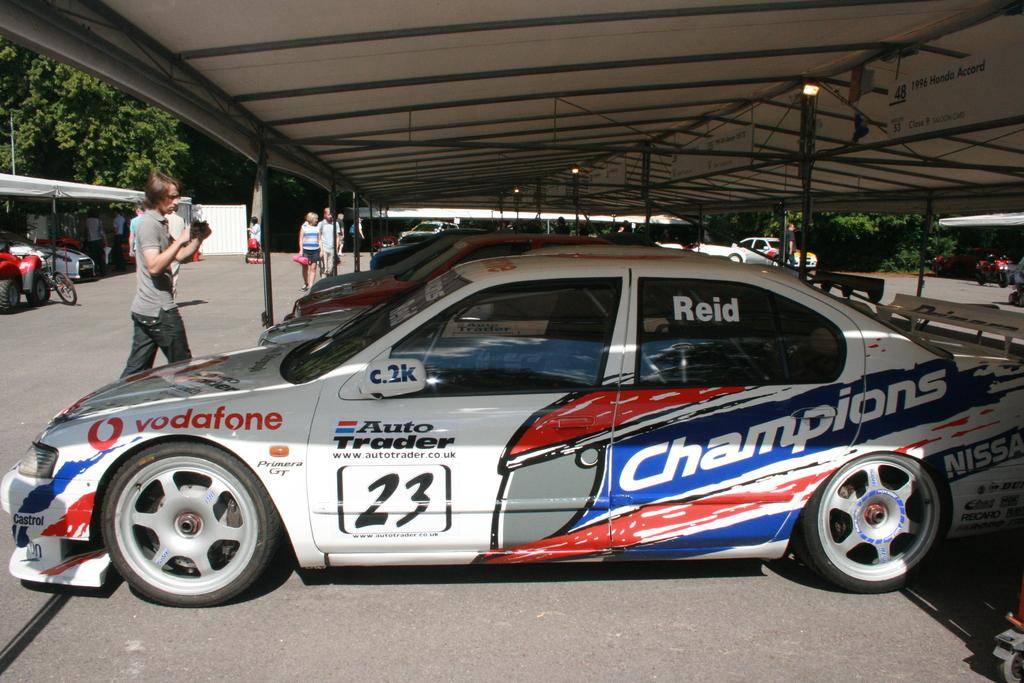What type of vehicles are under the shed in the image? There are cars under a shed in the image. Can you describe the other people in the image? There are other people in the image, but their specific actions or characteristics are not mentioned in the facts. What other types of vehicles are present in the image? There are vehicles other than cars in the image, but their specific types are not mentioned in the facts. What type of natural elements can be seen in the image? There are trees in the image. What type of cork can be seen floating in the water near the dock in the image? There is no dock, water, or cork present in the image. 